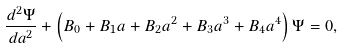<formula> <loc_0><loc_0><loc_500><loc_500>\frac { d ^ { 2 } \Psi } { d a ^ { 2 } } + \left ( B _ { 0 } + B _ { 1 } a + B _ { 2 } a ^ { 2 } + B _ { 3 } a ^ { 3 } + B _ { 4 } a ^ { 4 } \right ) \Psi = 0 ,</formula> 